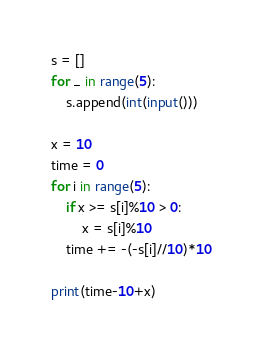Convert code to text. <code><loc_0><loc_0><loc_500><loc_500><_Python_>s = []
for _ in range(5):
	s.append(int(input()))

x = 10
time = 0
for i in range(5):
	if x >= s[i]%10 > 0:
		x = s[i]%10
	time += -(-s[i]//10)*10

print(time-10+x)</code> 